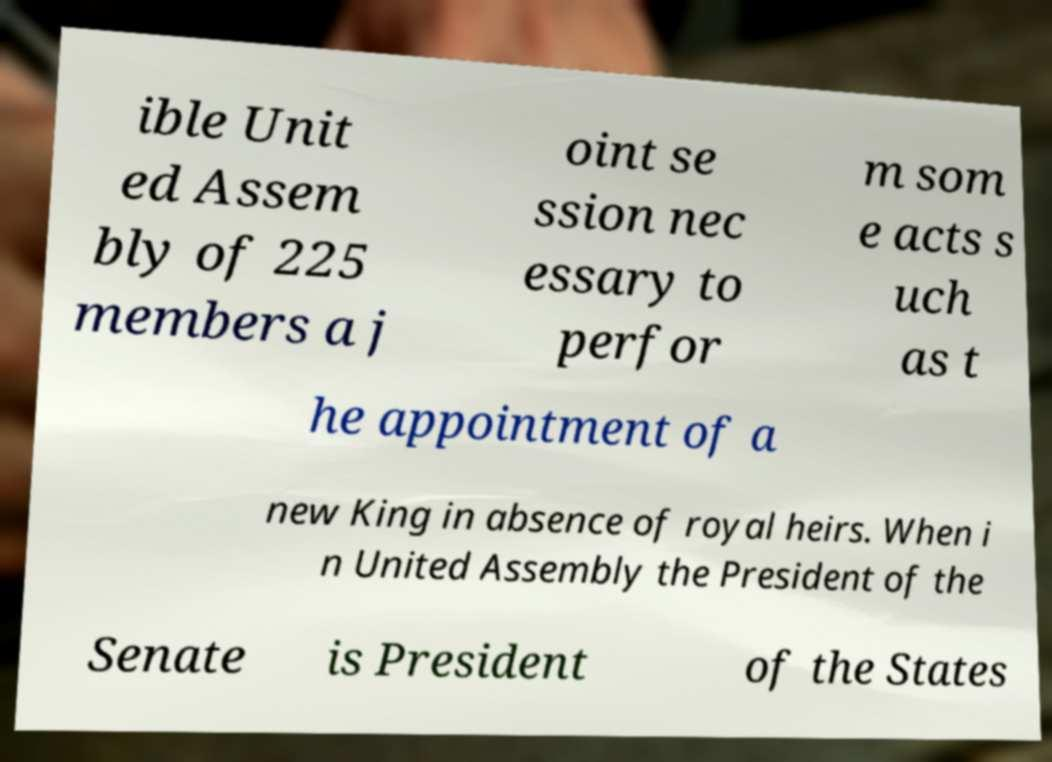Please read and relay the text visible in this image. What does it say? ible Unit ed Assem bly of 225 members a j oint se ssion nec essary to perfor m som e acts s uch as t he appointment of a new King in absence of royal heirs. When i n United Assembly the President of the Senate is President of the States 